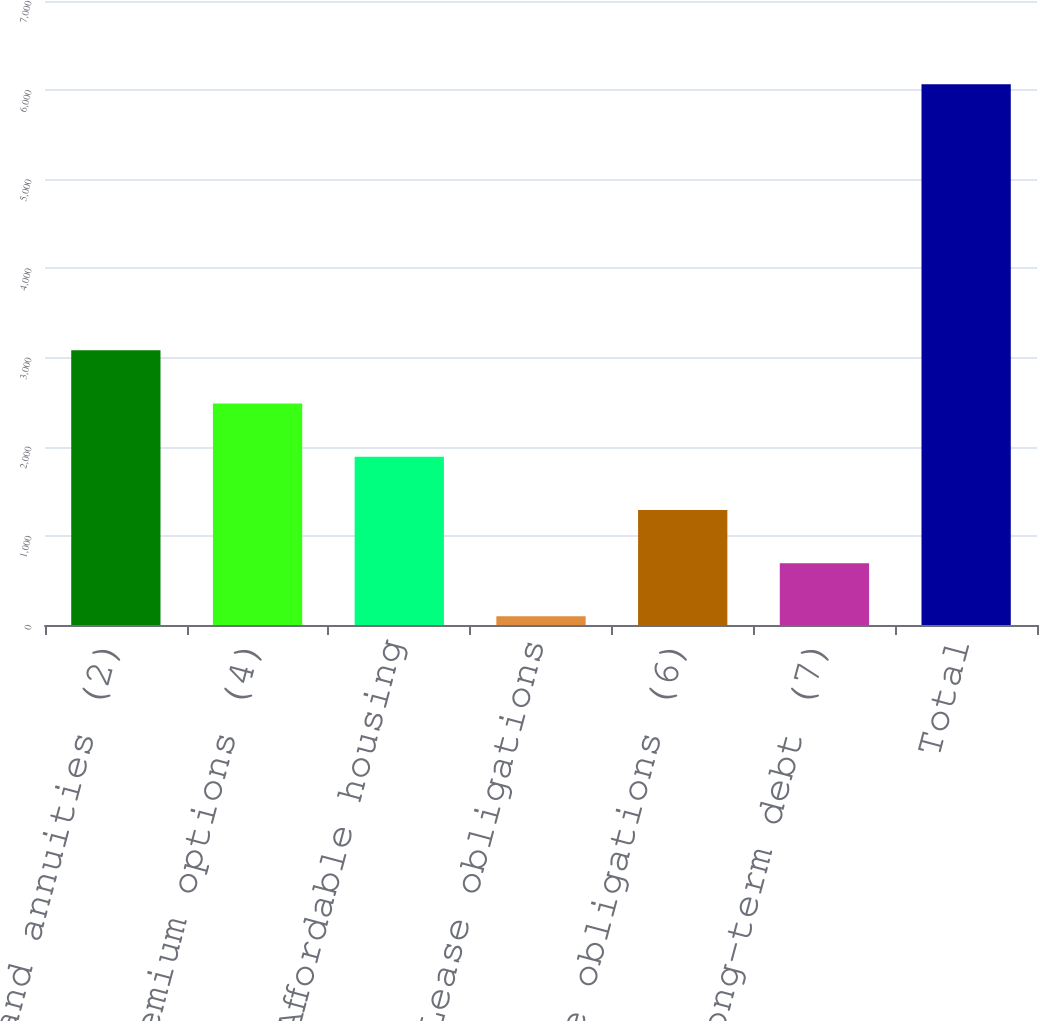<chart> <loc_0><loc_0><loc_500><loc_500><bar_chart><fcel>Insurance and annuities (2)<fcel>Deferred premium options (4)<fcel>Affordable housing<fcel>Lease obligations<fcel>Purchase obligations (6)<fcel>Interest on long-term debt (7)<fcel>Total<nl><fcel>3081.5<fcel>2484.6<fcel>1887.7<fcel>97<fcel>1290.8<fcel>693.9<fcel>6066<nl></chart> 